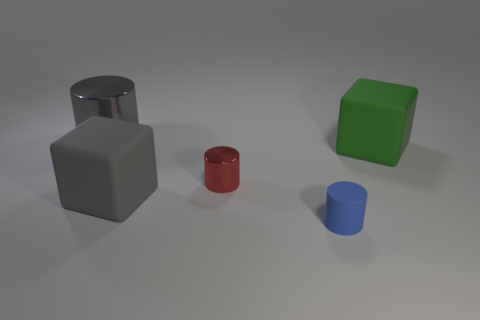Add 2 tiny yellow shiny balls. How many objects exist? 7 Subtract all blocks. How many objects are left? 3 Add 3 blue cylinders. How many blue cylinders exist? 4 Subtract 1 gray cylinders. How many objects are left? 4 Subtract all big rubber things. Subtract all small blue objects. How many objects are left? 2 Add 5 small red shiny things. How many small red shiny things are left? 6 